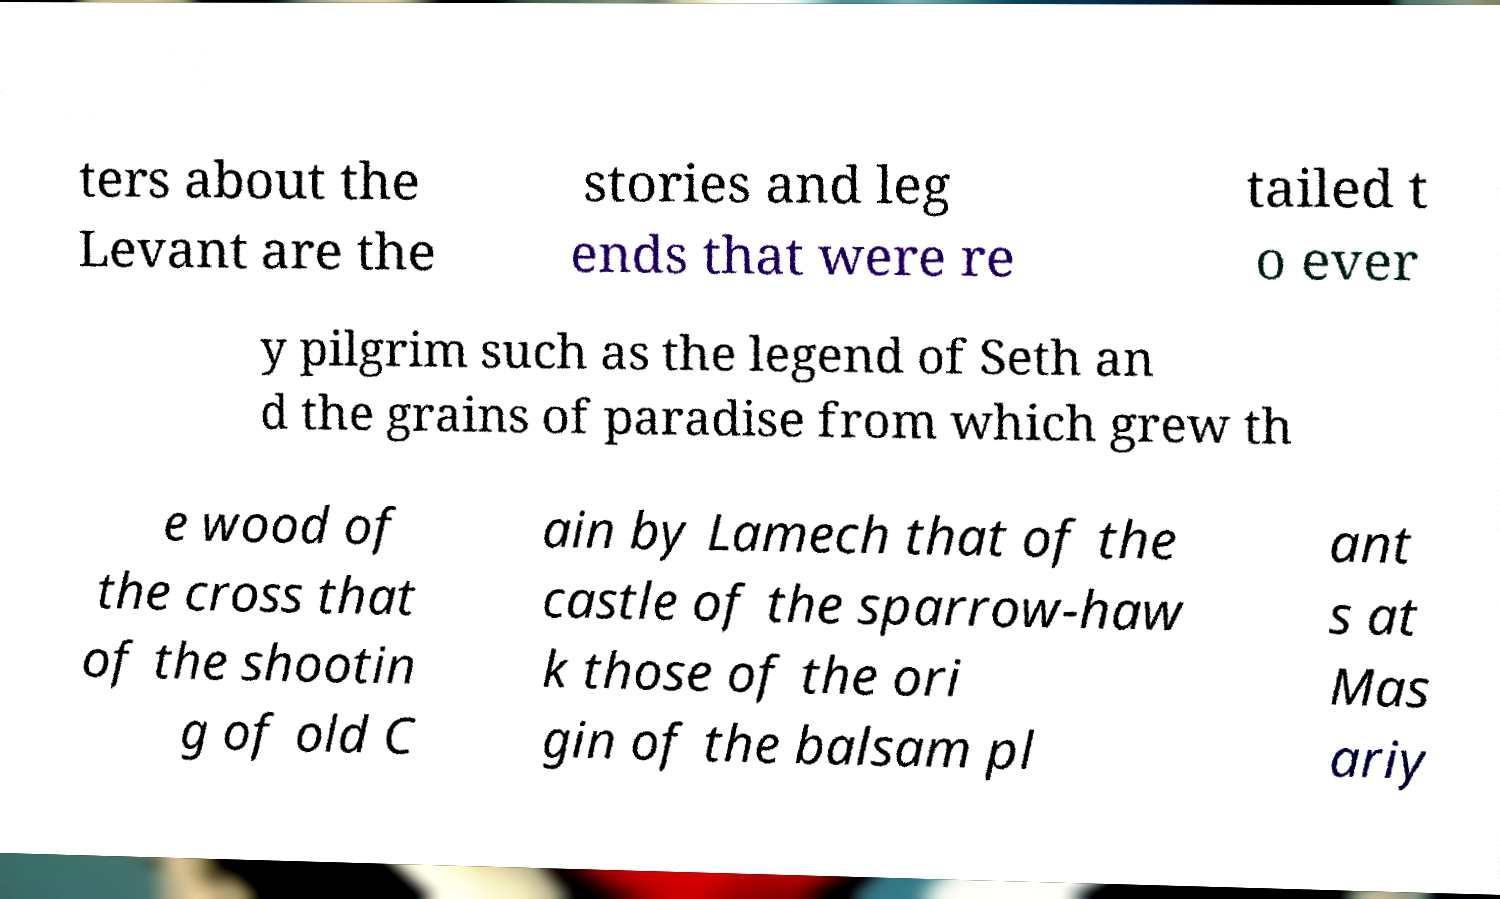Can you accurately transcribe the text from the provided image for me? ters about the Levant are the stories and leg ends that were re tailed t o ever y pilgrim such as the legend of Seth an d the grains of paradise from which grew th e wood of the cross that of the shootin g of old C ain by Lamech that of the castle of the sparrow-haw k those of the ori gin of the balsam pl ant s at Mas ariy 